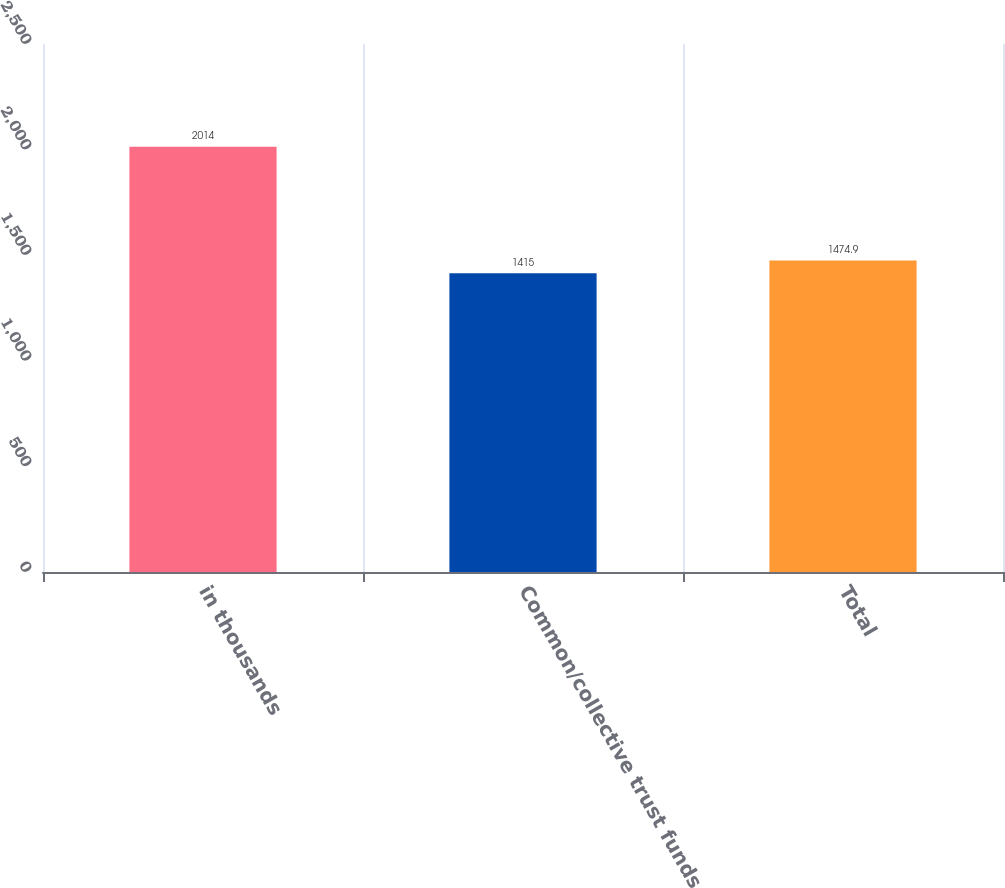<chart> <loc_0><loc_0><loc_500><loc_500><bar_chart><fcel>in thousands<fcel>Common/collective trust funds<fcel>Total<nl><fcel>2014<fcel>1415<fcel>1474.9<nl></chart> 